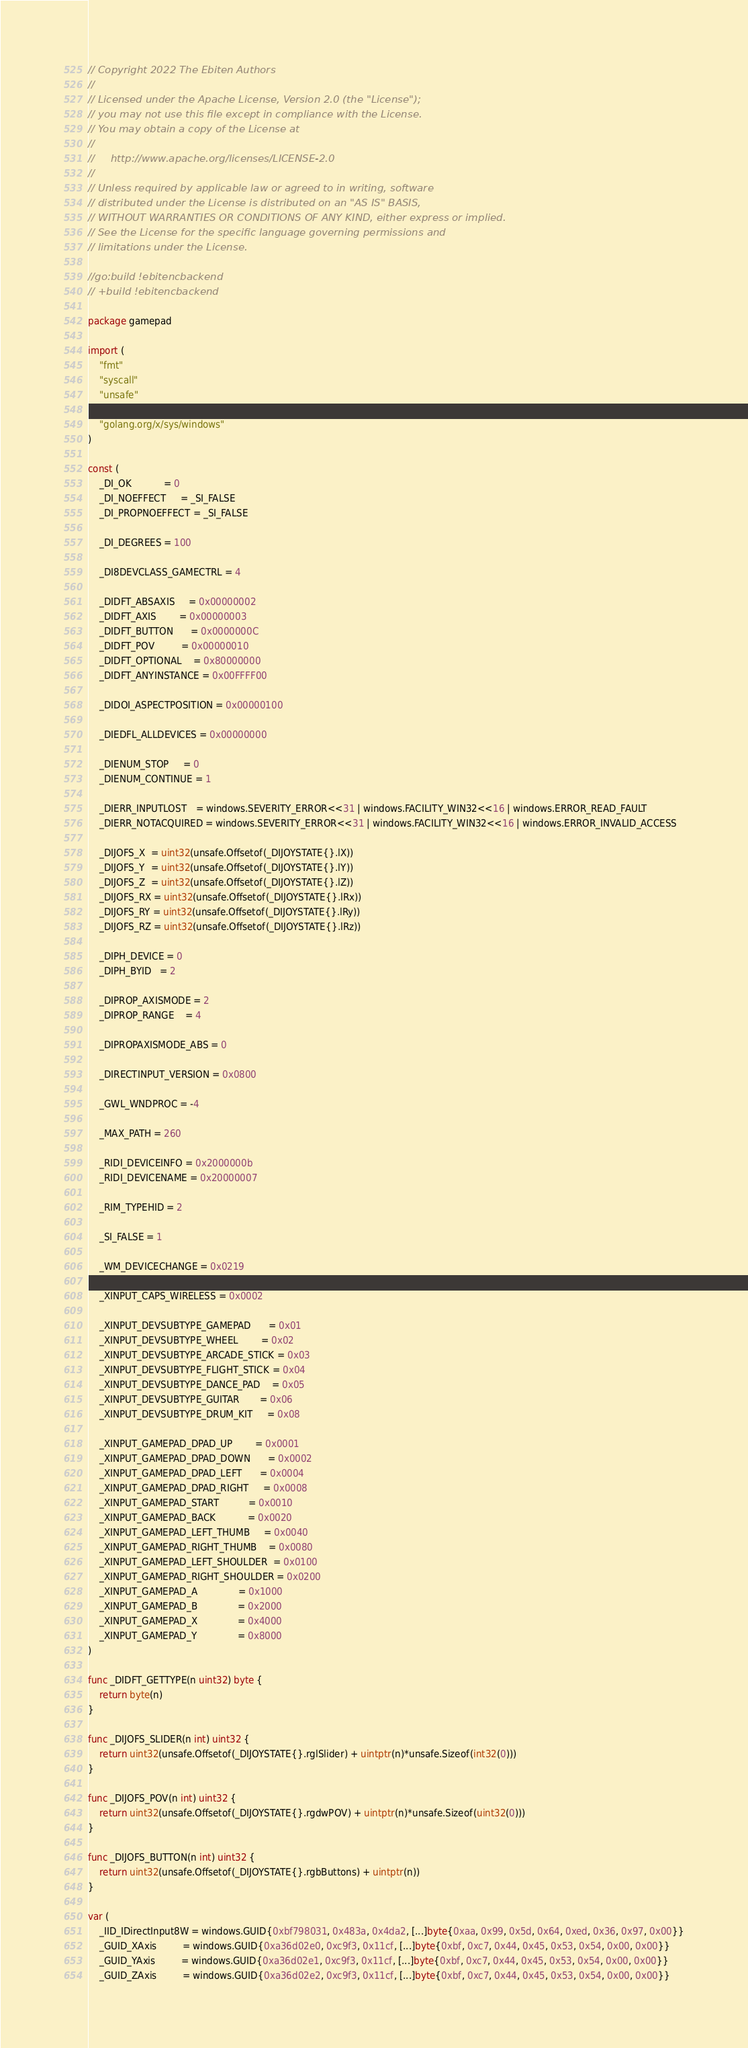Convert code to text. <code><loc_0><loc_0><loc_500><loc_500><_Go_>// Copyright 2022 The Ebiten Authors
//
// Licensed under the Apache License, Version 2.0 (the "License");
// you may not use this file except in compliance with the License.
// You may obtain a copy of the License at
//
//     http://www.apache.org/licenses/LICENSE-2.0
//
// Unless required by applicable law or agreed to in writing, software
// distributed under the License is distributed on an "AS IS" BASIS,
// WITHOUT WARRANTIES OR CONDITIONS OF ANY KIND, either express or implied.
// See the License for the specific language governing permissions and
// limitations under the License.

//go:build !ebitencbackend
// +build !ebitencbackend

package gamepad

import (
	"fmt"
	"syscall"
	"unsafe"

	"golang.org/x/sys/windows"
)

const (
	_DI_OK           = 0
	_DI_NOEFFECT     = _SI_FALSE
	_DI_PROPNOEFFECT = _SI_FALSE

	_DI_DEGREES = 100

	_DI8DEVCLASS_GAMECTRL = 4

	_DIDFT_ABSAXIS     = 0x00000002
	_DIDFT_AXIS        = 0x00000003
	_DIDFT_BUTTON      = 0x0000000C
	_DIDFT_POV         = 0x00000010
	_DIDFT_OPTIONAL    = 0x80000000
	_DIDFT_ANYINSTANCE = 0x00FFFF00

	_DIDOI_ASPECTPOSITION = 0x00000100

	_DIEDFL_ALLDEVICES = 0x00000000

	_DIENUM_STOP     = 0
	_DIENUM_CONTINUE = 1

	_DIERR_INPUTLOST   = windows.SEVERITY_ERROR<<31 | windows.FACILITY_WIN32<<16 | windows.ERROR_READ_FAULT
	_DIERR_NOTACQUIRED = windows.SEVERITY_ERROR<<31 | windows.FACILITY_WIN32<<16 | windows.ERROR_INVALID_ACCESS

	_DIJOFS_X  = uint32(unsafe.Offsetof(_DIJOYSTATE{}.lX))
	_DIJOFS_Y  = uint32(unsafe.Offsetof(_DIJOYSTATE{}.lY))
	_DIJOFS_Z  = uint32(unsafe.Offsetof(_DIJOYSTATE{}.lZ))
	_DIJOFS_RX = uint32(unsafe.Offsetof(_DIJOYSTATE{}.lRx))
	_DIJOFS_RY = uint32(unsafe.Offsetof(_DIJOYSTATE{}.lRy))
	_DIJOFS_RZ = uint32(unsafe.Offsetof(_DIJOYSTATE{}.lRz))

	_DIPH_DEVICE = 0
	_DIPH_BYID   = 2

	_DIPROP_AXISMODE = 2
	_DIPROP_RANGE    = 4

	_DIPROPAXISMODE_ABS = 0

	_DIRECTINPUT_VERSION = 0x0800

	_GWL_WNDPROC = -4

	_MAX_PATH = 260

	_RIDI_DEVICEINFO = 0x2000000b
	_RIDI_DEVICENAME = 0x20000007

	_RIM_TYPEHID = 2

	_SI_FALSE = 1

	_WM_DEVICECHANGE = 0x0219

	_XINPUT_CAPS_WIRELESS = 0x0002

	_XINPUT_DEVSUBTYPE_GAMEPAD      = 0x01
	_XINPUT_DEVSUBTYPE_WHEEL        = 0x02
	_XINPUT_DEVSUBTYPE_ARCADE_STICK = 0x03
	_XINPUT_DEVSUBTYPE_FLIGHT_STICK = 0x04
	_XINPUT_DEVSUBTYPE_DANCE_PAD    = 0x05
	_XINPUT_DEVSUBTYPE_GUITAR       = 0x06
	_XINPUT_DEVSUBTYPE_DRUM_KIT     = 0x08

	_XINPUT_GAMEPAD_DPAD_UP        = 0x0001
	_XINPUT_GAMEPAD_DPAD_DOWN      = 0x0002
	_XINPUT_GAMEPAD_DPAD_LEFT      = 0x0004
	_XINPUT_GAMEPAD_DPAD_RIGHT     = 0x0008
	_XINPUT_GAMEPAD_START          = 0x0010
	_XINPUT_GAMEPAD_BACK           = 0x0020
	_XINPUT_GAMEPAD_LEFT_THUMB     = 0x0040
	_XINPUT_GAMEPAD_RIGHT_THUMB    = 0x0080
	_XINPUT_GAMEPAD_LEFT_SHOULDER  = 0x0100
	_XINPUT_GAMEPAD_RIGHT_SHOULDER = 0x0200
	_XINPUT_GAMEPAD_A              = 0x1000
	_XINPUT_GAMEPAD_B              = 0x2000
	_XINPUT_GAMEPAD_X              = 0x4000
	_XINPUT_GAMEPAD_Y              = 0x8000
)

func _DIDFT_GETTYPE(n uint32) byte {
	return byte(n)
}

func _DIJOFS_SLIDER(n int) uint32 {
	return uint32(unsafe.Offsetof(_DIJOYSTATE{}.rglSlider) + uintptr(n)*unsafe.Sizeof(int32(0)))
}

func _DIJOFS_POV(n int) uint32 {
	return uint32(unsafe.Offsetof(_DIJOYSTATE{}.rgdwPOV) + uintptr(n)*unsafe.Sizeof(uint32(0)))
}

func _DIJOFS_BUTTON(n int) uint32 {
	return uint32(unsafe.Offsetof(_DIJOYSTATE{}.rgbButtons) + uintptr(n))
}

var (
	_IID_IDirectInput8W = windows.GUID{0xbf798031, 0x483a, 0x4da2, [...]byte{0xaa, 0x99, 0x5d, 0x64, 0xed, 0x36, 0x97, 0x00}}
	_GUID_XAxis         = windows.GUID{0xa36d02e0, 0xc9f3, 0x11cf, [...]byte{0xbf, 0xc7, 0x44, 0x45, 0x53, 0x54, 0x00, 0x00}}
	_GUID_YAxis         = windows.GUID{0xa36d02e1, 0xc9f3, 0x11cf, [...]byte{0xbf, 0xc7, 0x44, 0x45, 0x53, 0x54, 0x00, 0x00}}
	_GUID_ZAxis         = windows.GUID{0xa36d02e2, 0xc9f3, 0x11cf, [...]byte{0xbf, 0xc7, 0x44, 0x45, 0x53, 0x54, 0x00, 0x00}}</code> 